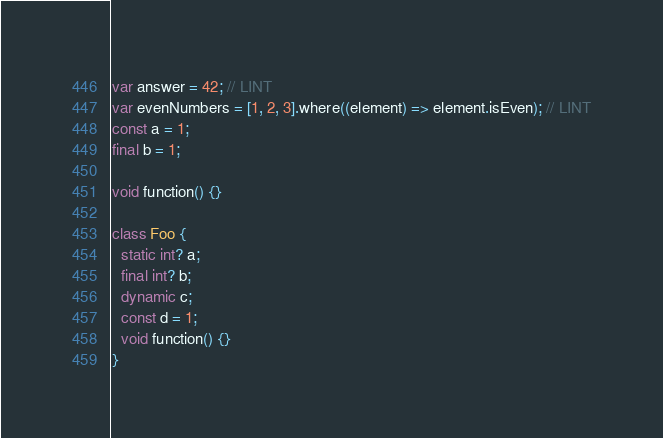<code> <loc_0><loc_0><loc_500><loc_500><_Dart_>var answer = 42; // LINT
var evenNumbers = [1, 2, 3].where((element) => element.isEven); // LINT
const a = 1;
final b = 1;

void function() {}

class Foo {
  static int? a;
  final int? b;
  dynamic c;
  const d = 1;
  void function() {}
}
</code> 